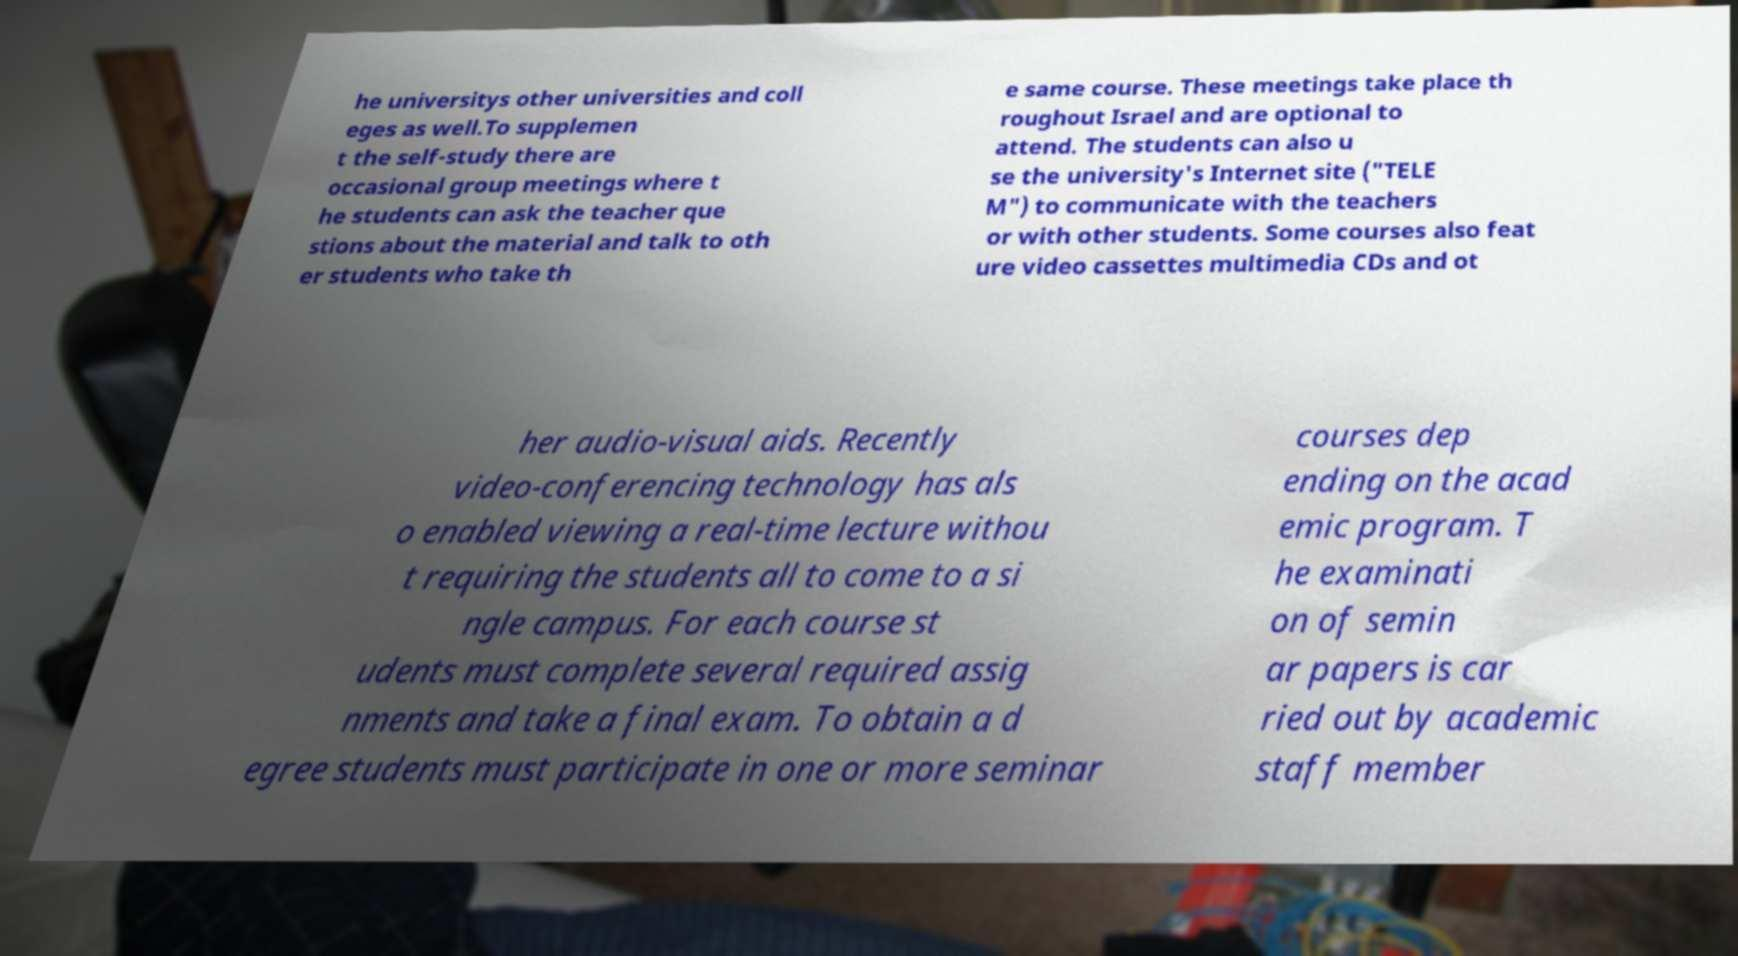Can you read and provide the text displayed in the image?This photo seems to have some interesting text. Can you extract and type it out for me? he universitys other universities and coll eges as well.To supplemen t the self-study there are occasional group meetings where t he students can ask the teacher que stions about the material and talk to oth er students who take th e same course. These meetings take place th roughout Israel and are optional to attend. The students can also u se the university's Internet site ("TELE M") to communicate with the teachers or with other students. Some courses also feat ure video cassettes multimedia CDs and ot her audio-visual aids. Recently video-conferencing technology has als o enabled viewing a real-time lecture withou t requiring the students all to come to a si ngle campus. For each course st udents must complete several required assig nments and take a final exam. To obtain a d egree students must participate in one or more seminar courses dep ending on the acad emic program. T he examinati on of semin ar papers is car ried out by academic staff member 